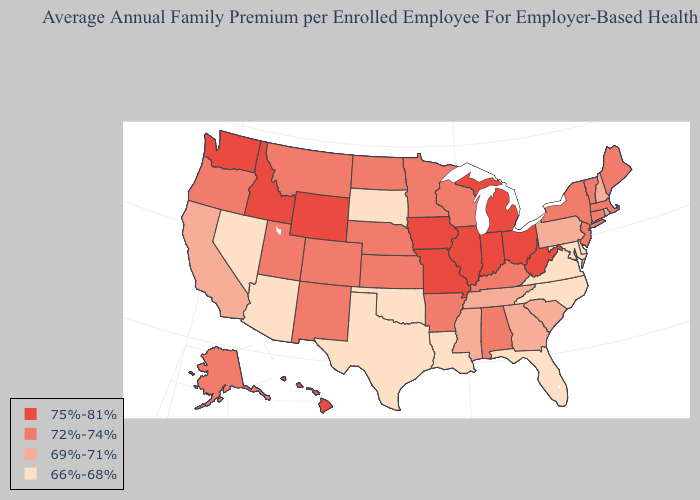Does Ohio have the same value as Washington?
Keep it brief. Yes. Does Minnesota have the lowest value in the MidWest?
Concise answer only. No. Name the states that have a value in the range 72%-74%?
Concise answer only. Alabama, Alaska, Arkansas, Colorado, Connecticut, Kansas, Kentucky, Maine, Massachusetts, Minnesota, Montana, Nebraska, New Jersey, New Mexico, New York, North Dakota, Oregon, Utah, Vermont, Wisconsin. Does Oregon have a lower value than Missouri?
Answer briefly. Yes. What is the value of Alabama?
Give a very brief answer. 72%-74%. Which states hav the highest value in the MidWest?
Quick response, please. Illinois, Indiana, Iowa, Michigan, Missouri, Ohio. What is the lowest value in the USA?
Quick response, please. 66%-68%. Name the states that have a value in the range 72%-74%?
Answer briefly. Alabama, Alaska, Arkansas, Colorado, Connecticut, Kansas, Kentucky, Maine, Massachusetts, Minnesota, Montana, Nebraska, New Jersey, New Mexico, New York, North Dakota, Oregon, Utah, Vermont, Wisconsin. Name the states that have a value in the range 72%-74%?
Quick response, please. Alabama, Alaska, Arkansas, Colorado, Connecticut, Kansas, Kentucky, Maine, Massachusetts, Minnesota, Montana, Nebraska, New Jersey, New Mexico, New York, North Dakota, Oregon, Utah, Vermont, Wisconsin. What is the lowest value in the West?
Give a very brief answer. 66%-68%. Among the states that border Mississippi , which have the lowest value?
Answer briefly. Louisiana. What is the value of Minnesota?
Short answer required. 72%-74%. Name the states that have a value in the range 69%-71%?
Be succinct. California, Georgia, Mississippi, New Hampshire, Pennsylvania, Rhode Island, South Carolina, Tennessee. What is the lowest value in the South?
Quick response, please. 66%-68%. What is the value of Nevada?
Quick response, please. 66%-68%. 